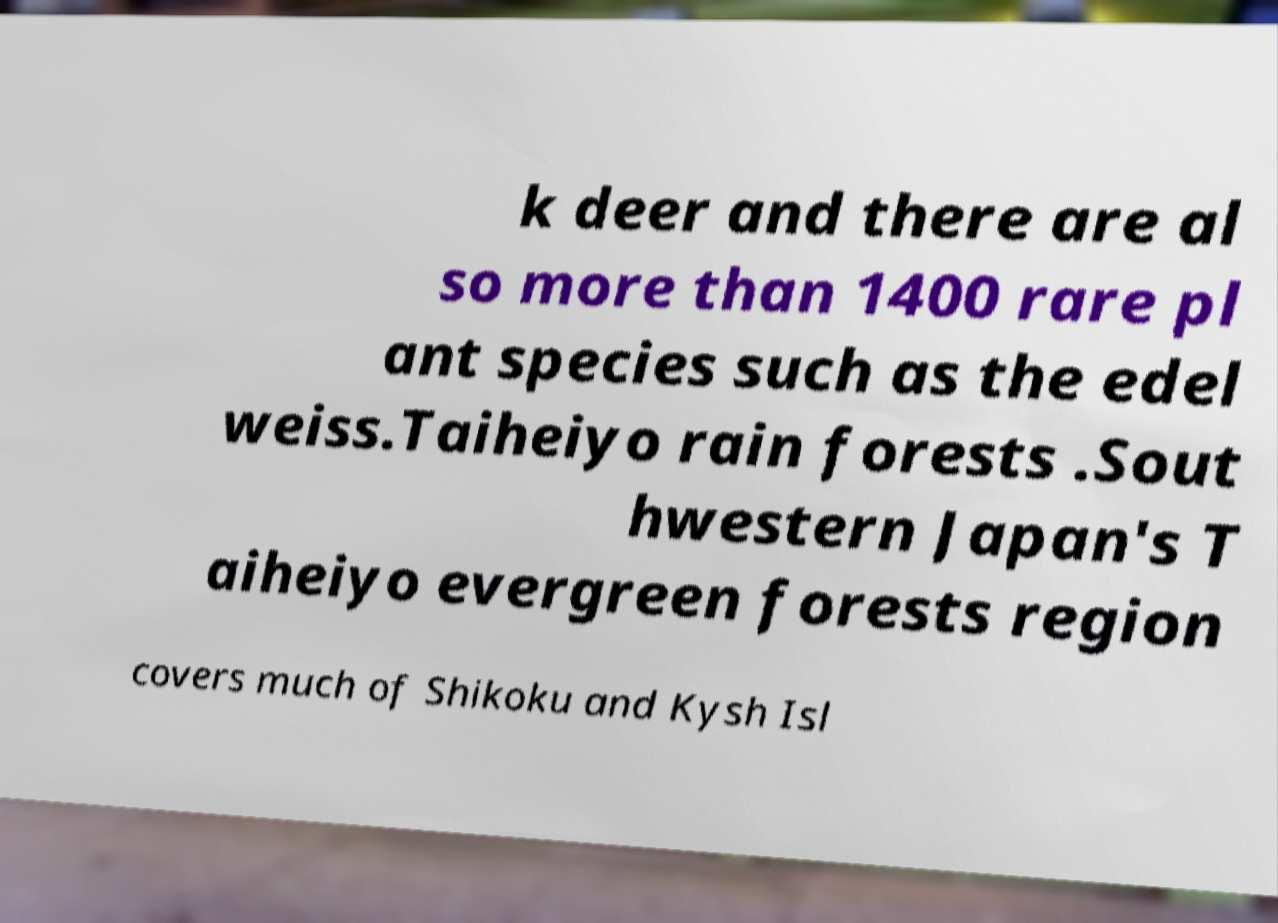Can you accurately transcribe the text from the provided image for me? k deer and there are al so more than 1400 rare pl ant species such as the edel weiss.Taiheiyo rain forests .Sout hwestern Japan's T aiheiyo evergreen forests region covers much of Shikoku and Kysh Isl 